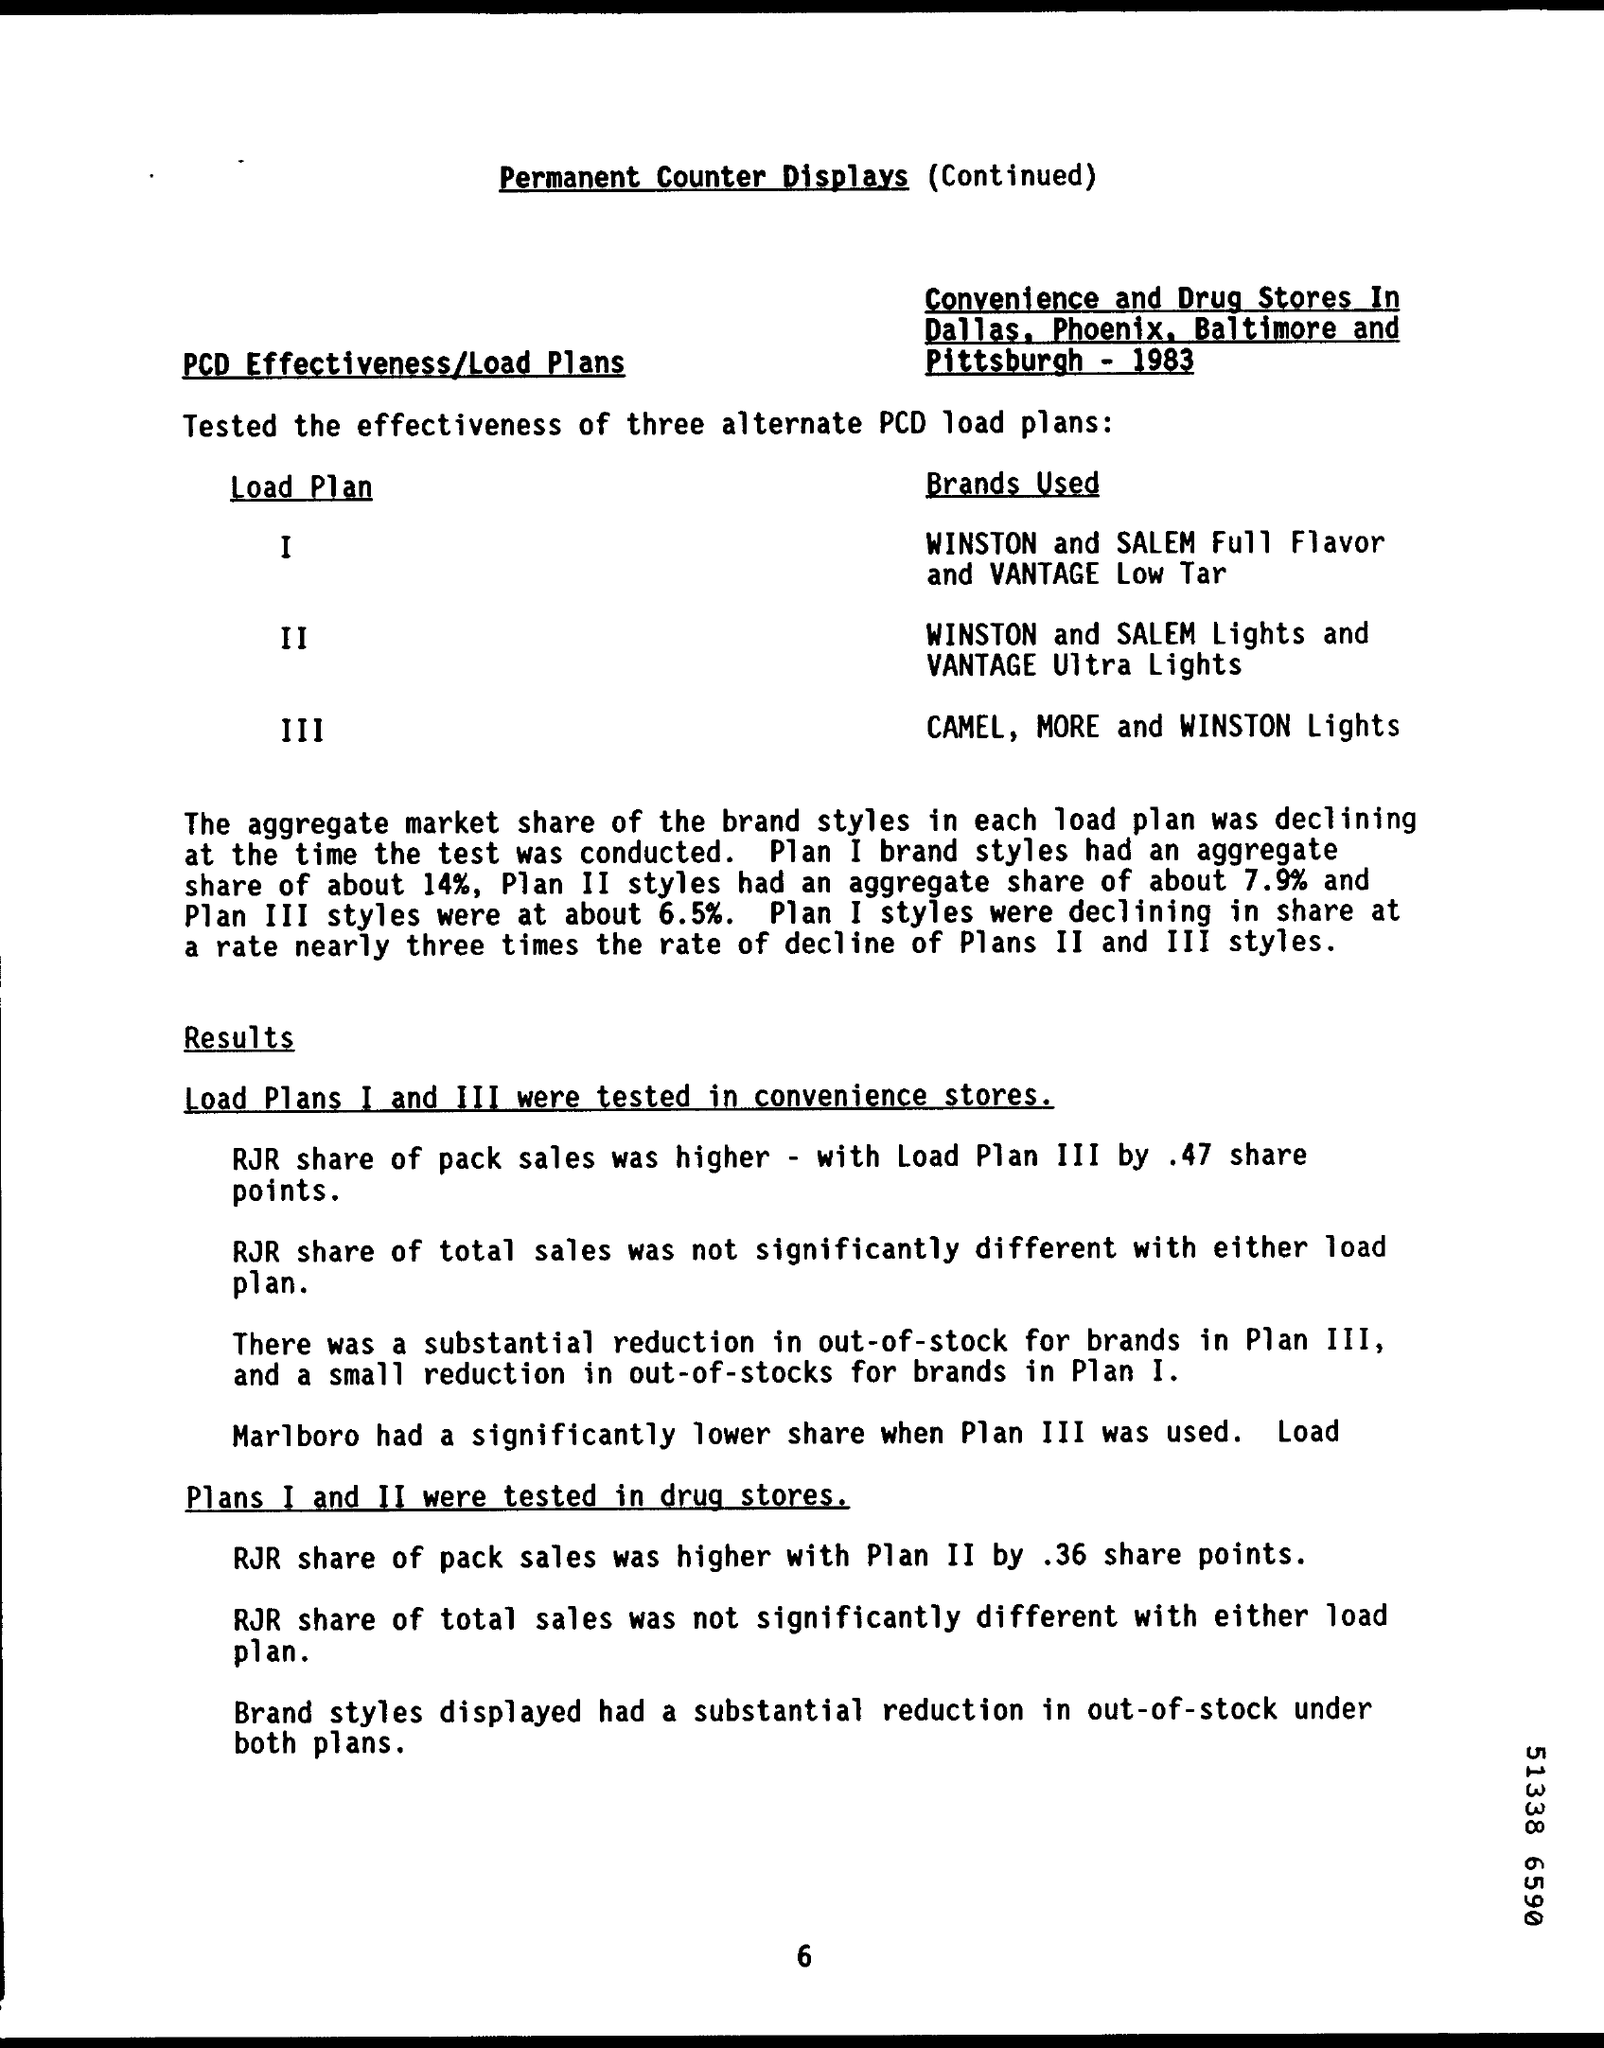What is the Title of the document?
Your response must be concise. Permanent Counter Displays (Continued). What is the aggregate share of Plan I brand styles?
Provide a succinct answer. 14%. What is the aggregate share of Plan II brand styles?
Your answer should be very brief. 7.9%. What is the aggregate share of Plan III brand styles?
Offer a very short reply. About 6.5%. 